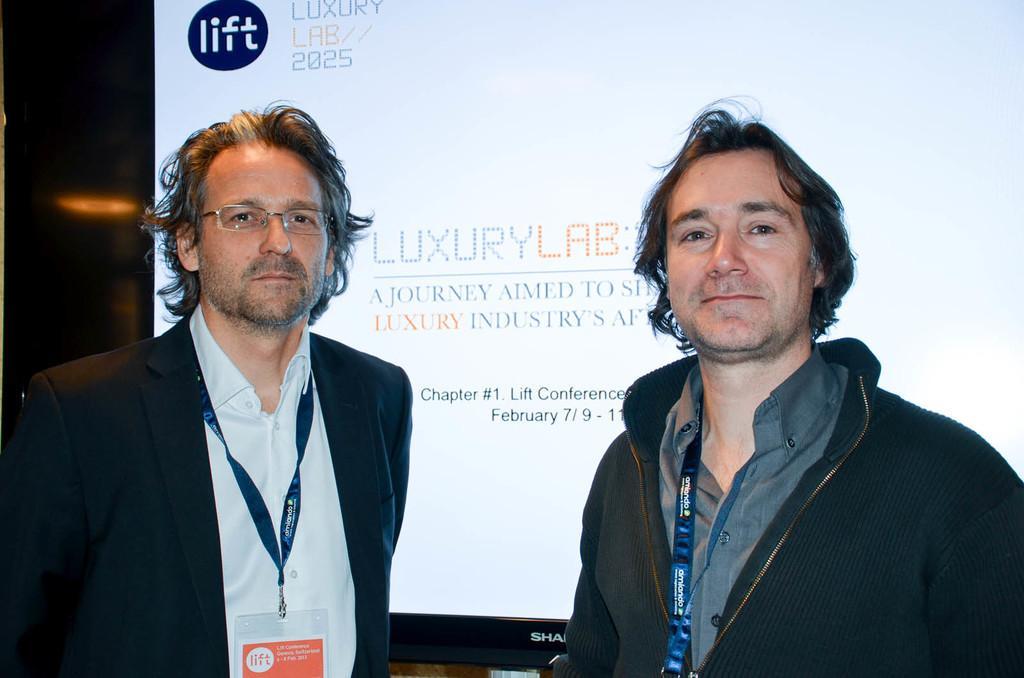What is the main object in the image? There is a screen in the image. Who or what is in front of the screen? There are two people standing in the front of the image. What can be observed about the two people? The two people are wearing ID cards around their necks. What type of store is visible in the background of the image? There is no store visible in the image; it only features a screen and two people with ID cards. What holiday is being celebrated by the people in the image? There is no indication of a holiday being celebrated in the image. 